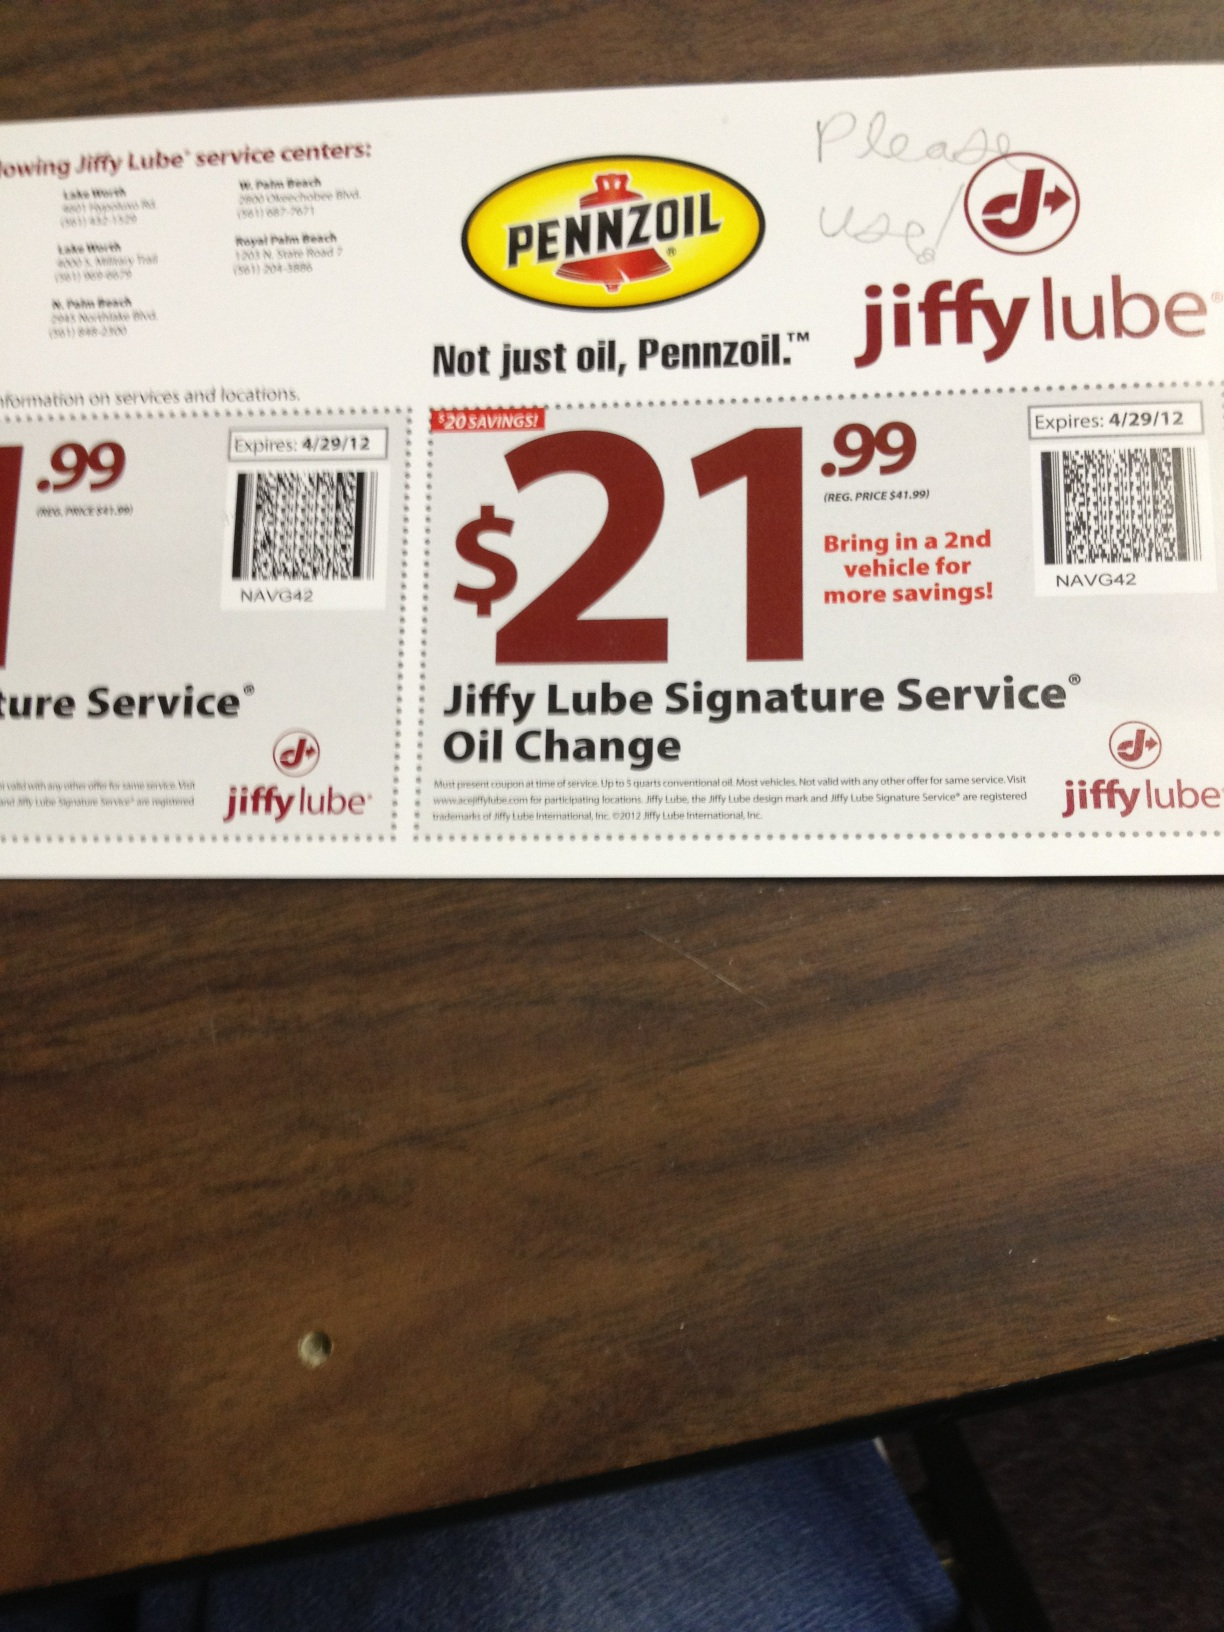If you could imagine an extraordinary scenario related to this coupon, what would it be? Imagine a futuristic scenario where your car is due for an oil change, but instead of driving to a service center, you upload a digital version of this coupon to your car's onboard AI. The AI then connects to a fleet of autonomous service robots that promptly arrive at your home, where they perform the oil change in your driveway. With their precision technology, the process is incredibly fast and efficient, leaving you with a seamlessly running vehicle without leaving the comfort of your home! 